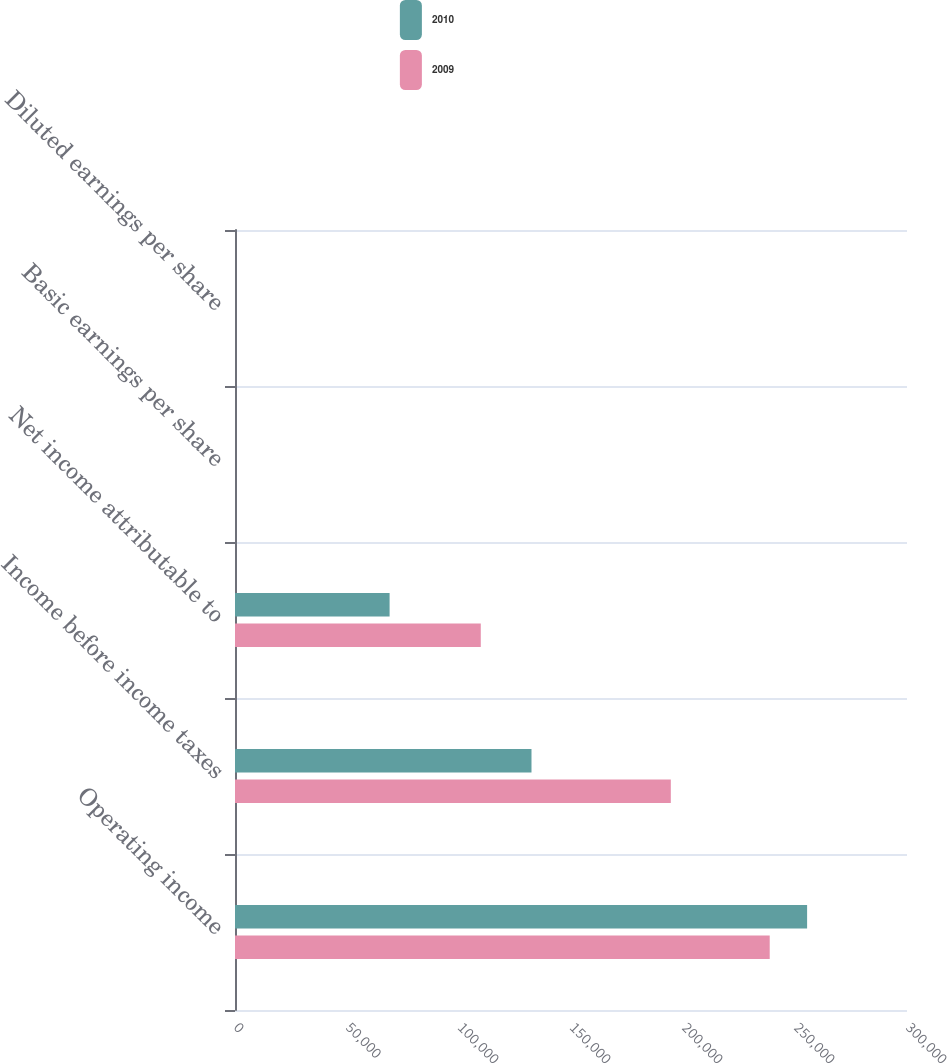<chart> <loc_0><loc_0><loc_500><loc_500><stacked_bar_chart><ecel><fcel>Operating income<fcel>Income before income taxes<fcel>Net income attributable to<fcel>Basic earnings per share<fcel>Diluted earnings per share<nl><fcel>2010<fcel>255405<fcel>132362<fcel>69020<fcel>0.71<fcel>0.7<nl><fcel>2009<fcel>238712<fcel>194563<fcel>109724<fcel>1.07<fcel>1.06<nl></chart> 